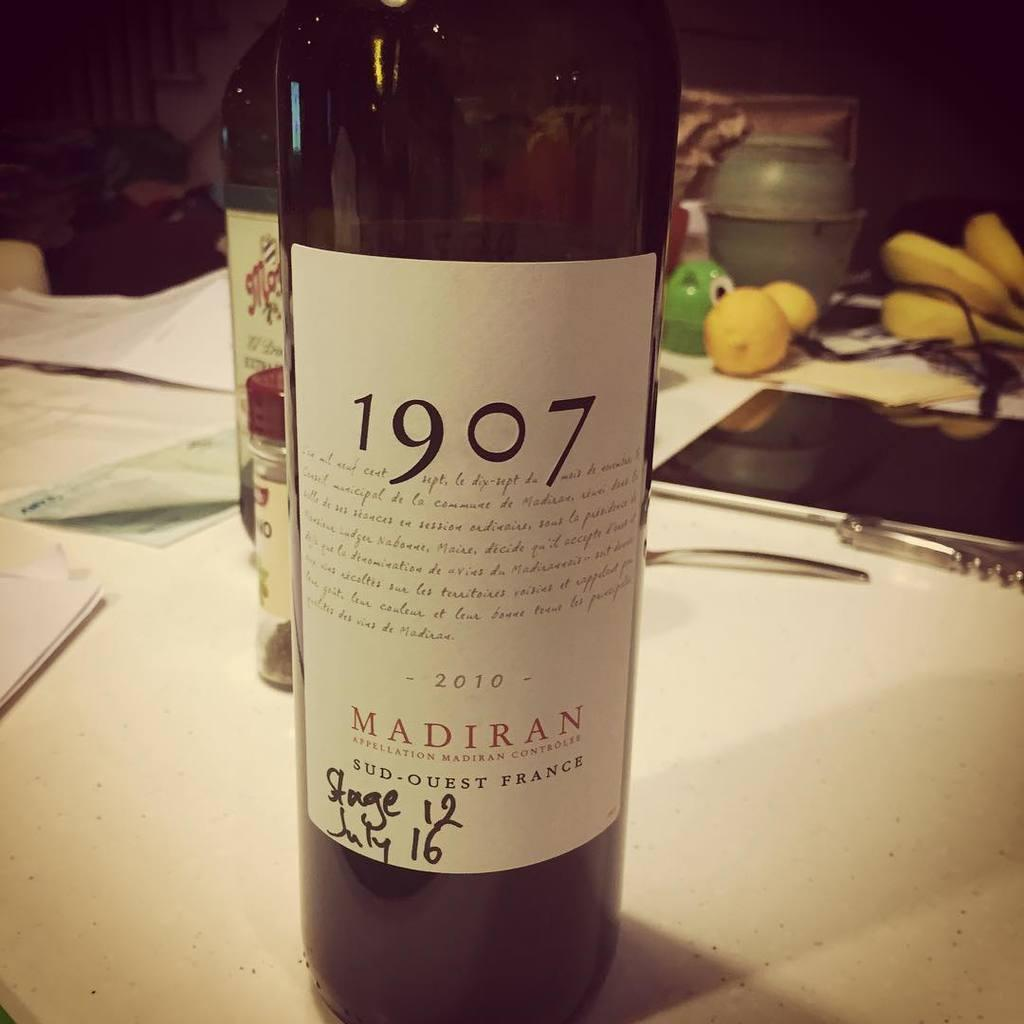<image>
Summarize the visual content of the image. A bottle of wine that says 1907 is on a counter with papers on it. 